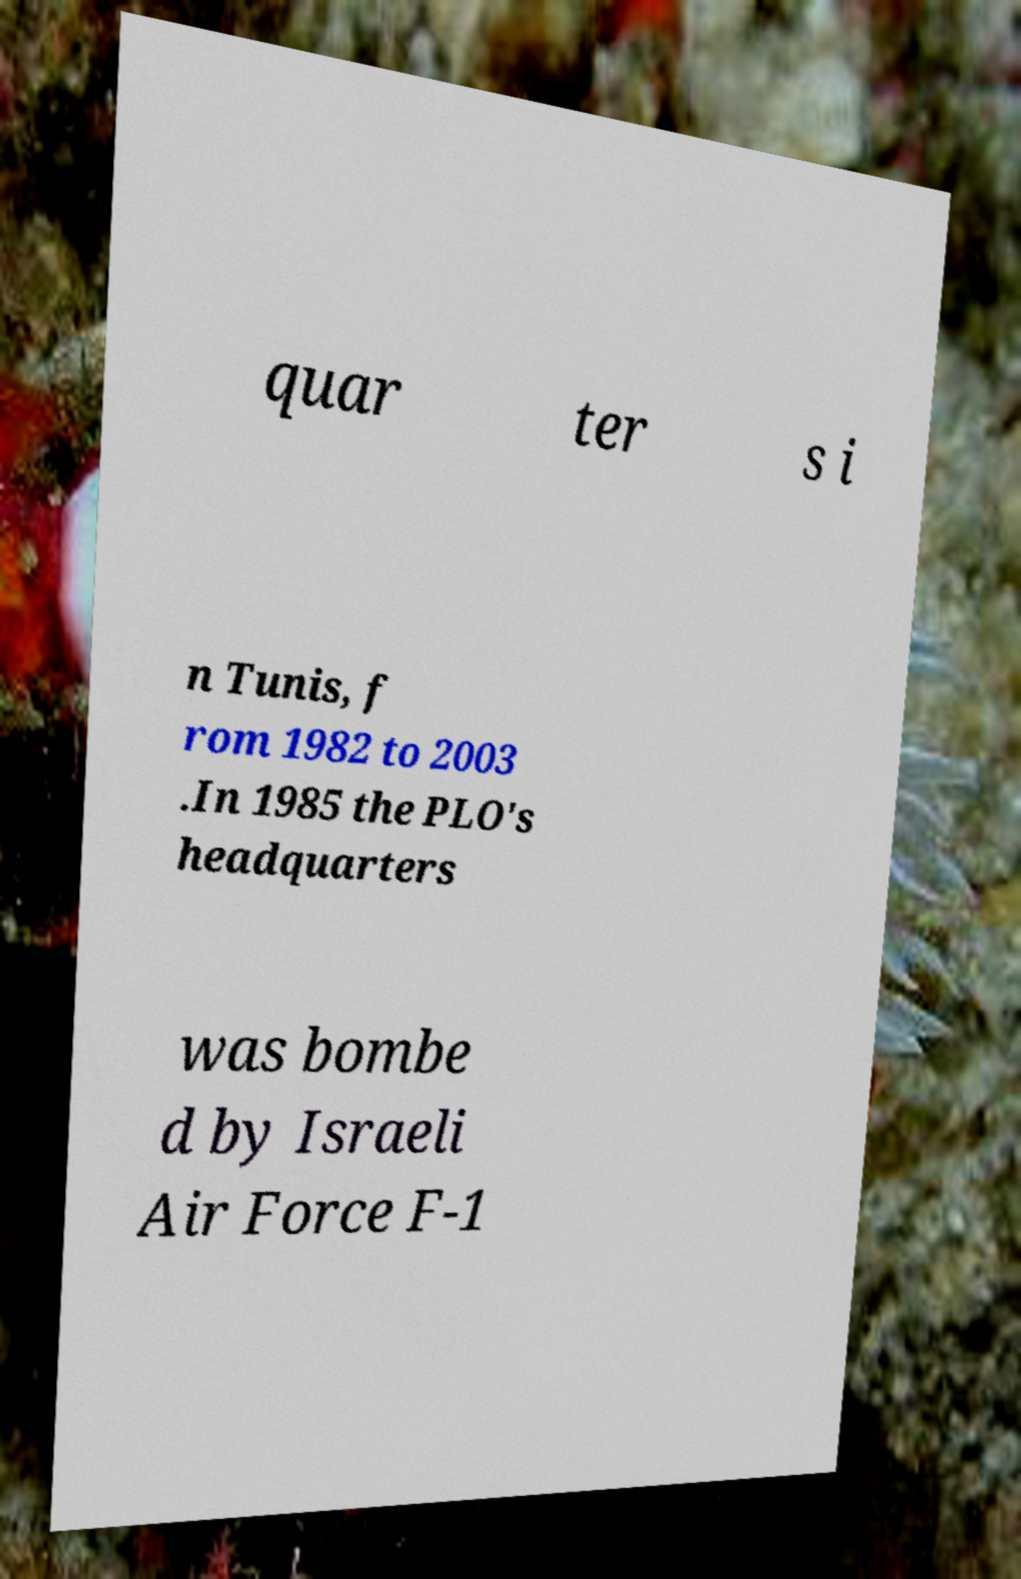Can you read and provide the text displayed in the image?This photo seems to have some interesting text. Can you extract and type it out for me? quar ter s i n Tunis, f rom 1982 to 2003 .In 1985 the PLO's headquarters was bombe d by Israeli Air Force F-1 